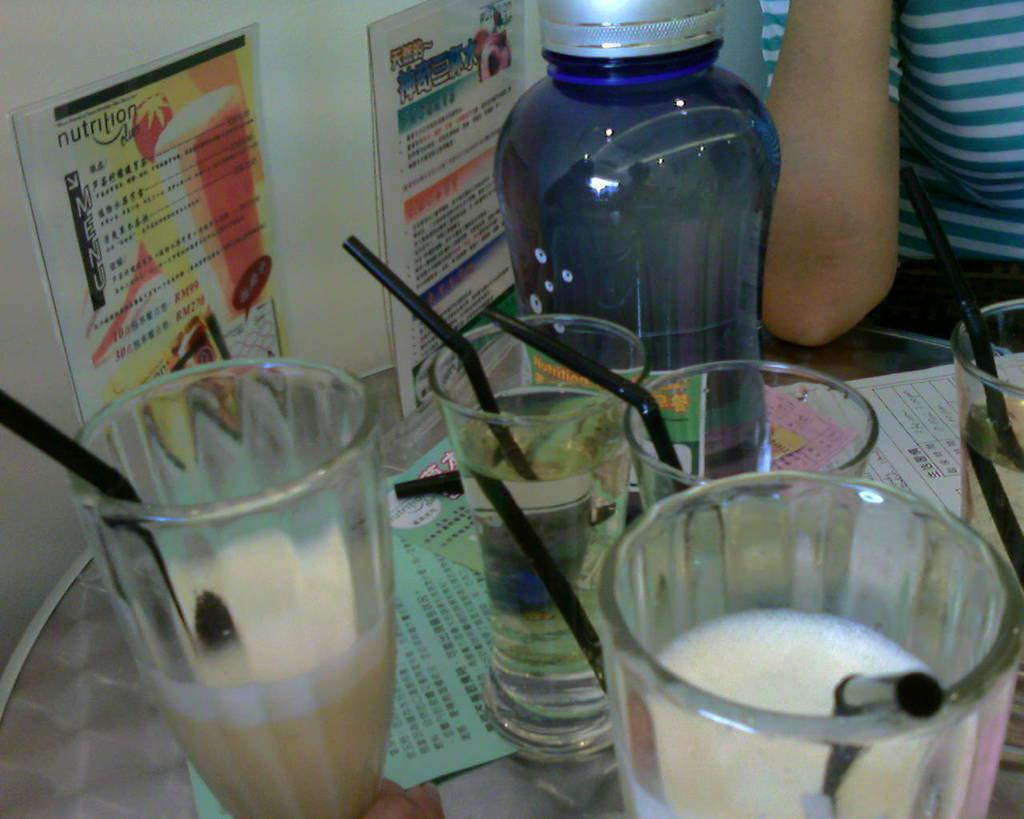What is on the table in the image? There is a glass, a bottle, and a paper on the table in the image. What can be seen on the wall in the image? There are posters on the wall in the image. What type of clock is hanging on the wall in the image? There is no clock visible in the image. Can you see a stream flowing in the background of the image? There is no stream present in the image. 